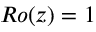<formula> <loc_0><loc_0><loc_500><loc_500>R o ( z ) = 1</formula> 